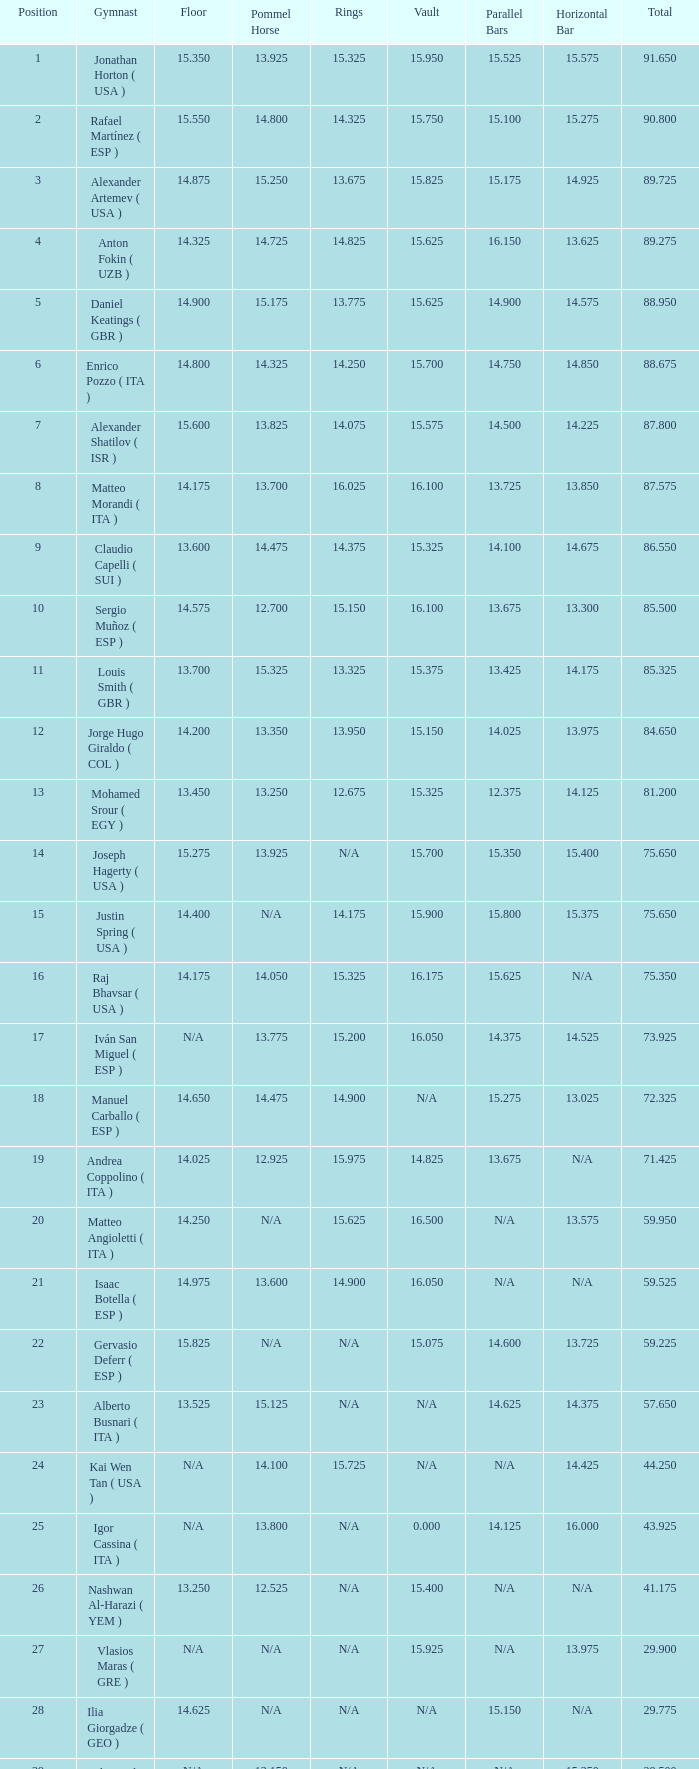If the parallel bars is 14.025, what is the total number of gymnasts? 1.0. 